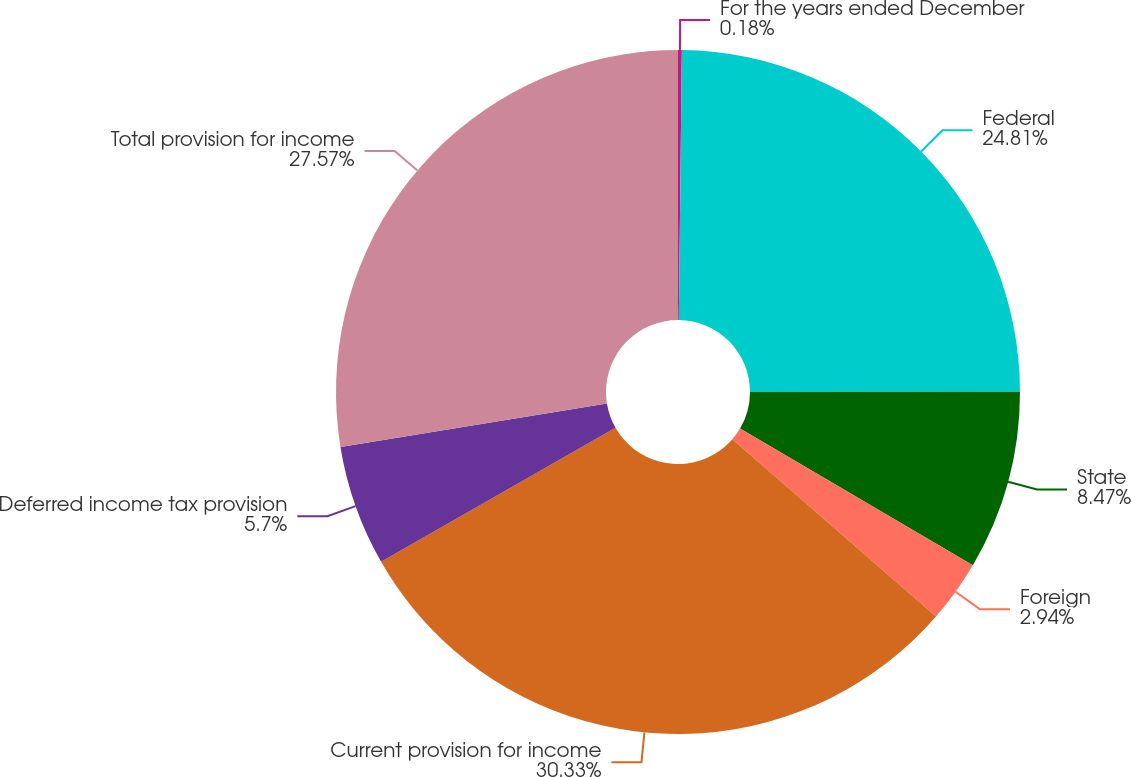<chart> <loc_0><loc_0><loc_500><loc_500><pie_chart><fcel>For the years ended December<fcel>Federal<fcel>State<fcel>Foreign<fcel>Current provision for income<fcel>Deferred income tax provision<fcel>Total provision for income<nl><fcel>0.18%<fcel>24.81%<fcel>8.47%<fcel>2.94%<fcel>30.34%<fcel>5.7%<fcel>27.57%<nl></chart> 